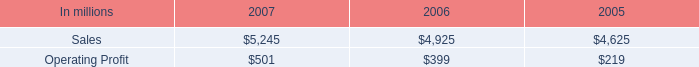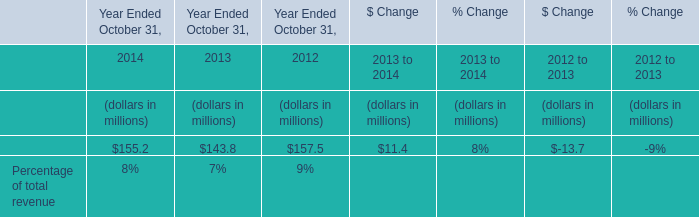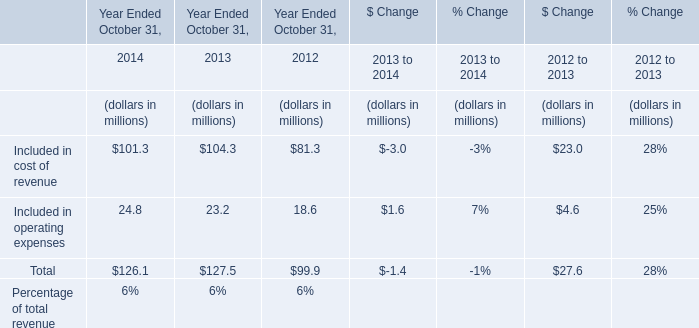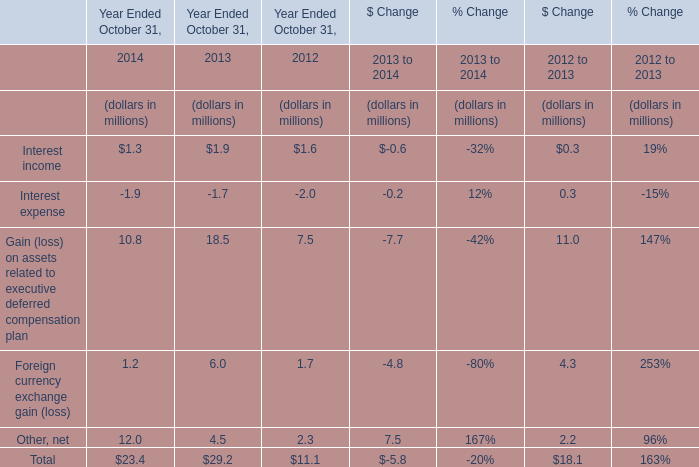What will Included in operating expenses reach in 2015 if it continues to grow at its current rate? (in million) 
Computations: (24.8 * (1 + ((24.8 - 23.2) / 23.2)))
Answer: 26.51034. 